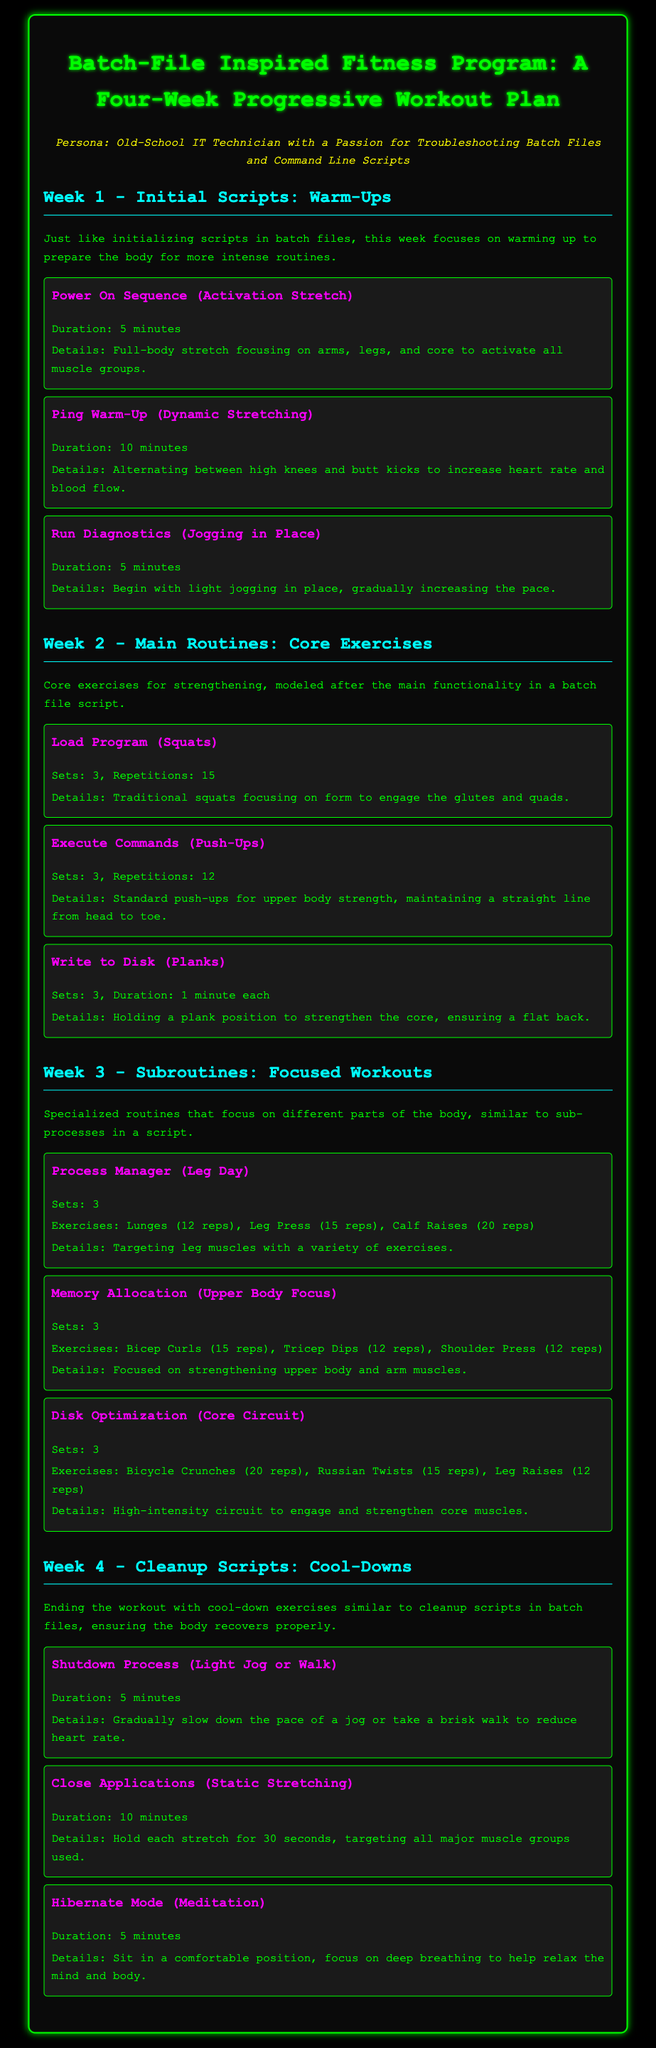What is the title of the program? The title is stated in the header of the document.
Answer: Batch-File Inspired Fitness Program: A Four-Week Progressive Workout Plan How long is the duration of the Power On Sequence? The duration of the Power On Sequence is mentioned in the warm-up section of Week 1.
Answer: 5 minutes What exercise corresponds to "Execute Commands"? This term is used in the context of core exercises, specifically referring to a particular workout.
Answer: Push-Ups How many sets of Lunges are in the "Process Manager" workout? This information can be found under the leg day section of Week 3.
Answer: 3 What is the focus of Week 4 in the program? The focus is described in the paragraph introducing Week 4 in the document.
Answer: Cool-Downs For how long should each stretch be held during "Close Applications"? It is mentioned specifically in the details of the workout under Week 4.
Answer: 30 seconds How many exercises are included in the "Disk Optimization" routine? This is indicated in the workout description under Week 3.
Answer: 3 What is the duration of the "Hibernate Mode" activity? The duration is specified in the cool-downs section of Week 4.
Answer: 5 minutes 